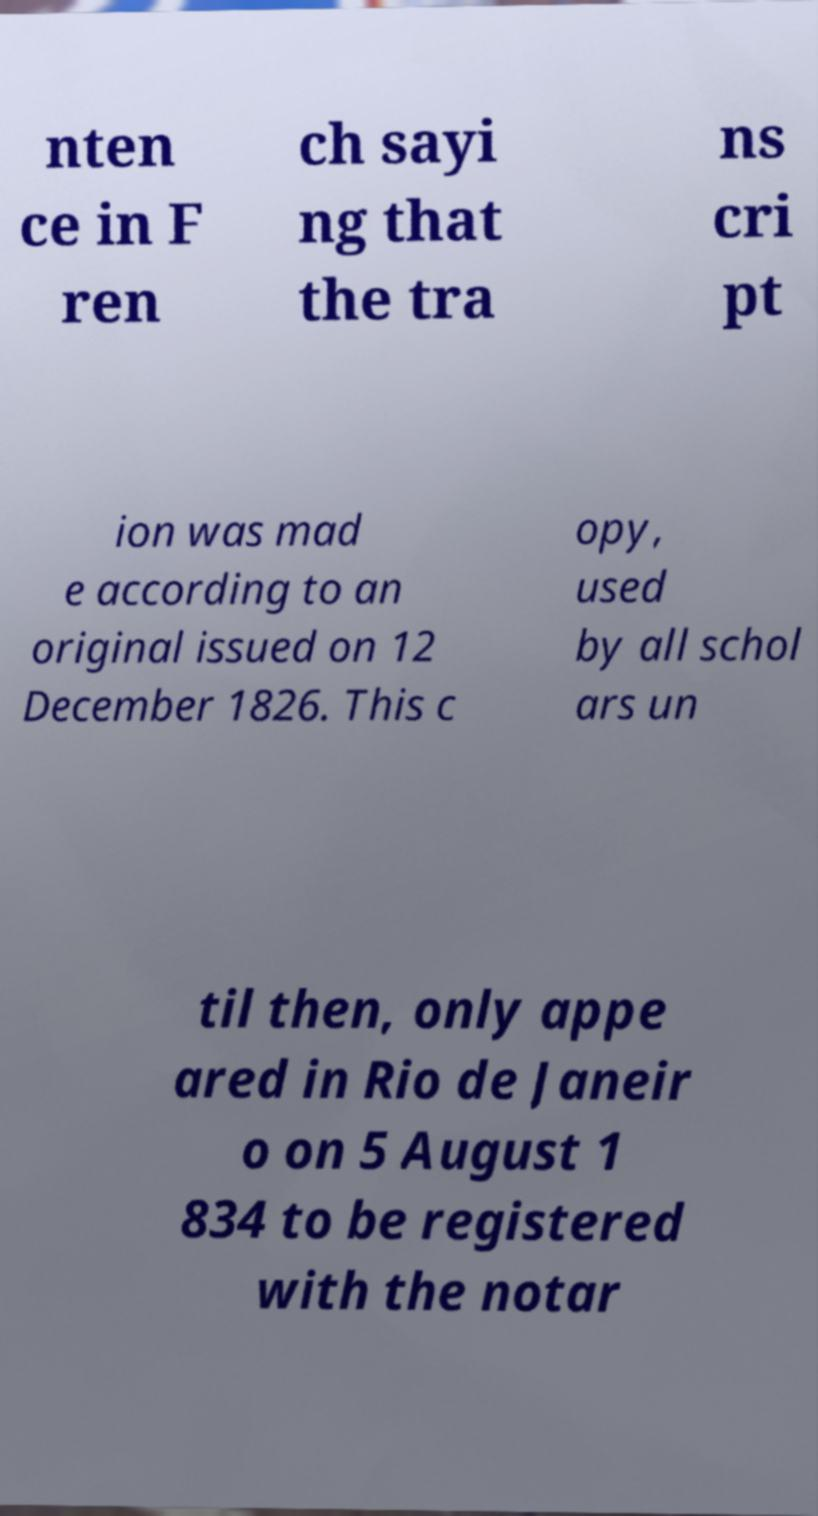Can you read and provide the text displayed in the image?This photo seems to have some interesting text. Can you extract and type it out for me? nten ce in F ren ch sayi ng that the tra ns cri pt ion was mad e according to an original issued on 12 December 1826. This c opy, used by all schol ars un til then, only appe ared in Rio de Janeir o on 5 August 1 834 to be registered with the notar 